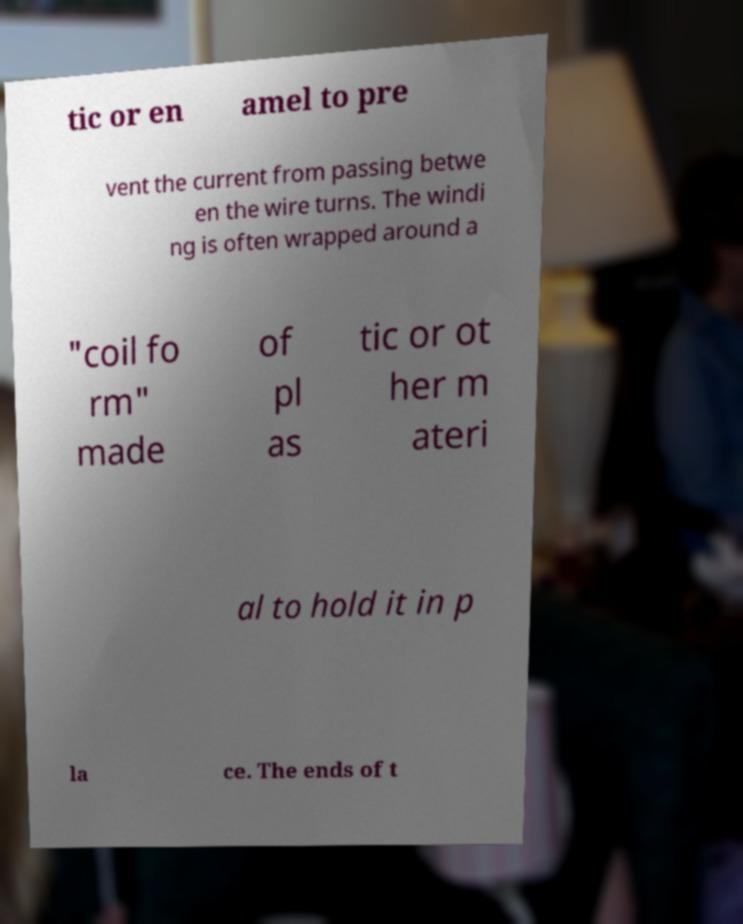There's text embedded in this image that I need extracted. Can you transcribe it verbatim? tic or en amel to pre vent the current from passing betwe en the wire turns. The windi ng is often wrapped around a "coil fo rm" made of pl as tic or ot her m ateri al to hold it in p la ce. The ends of t 